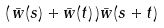Convert formula to latex. <formula><loc_0><loc_0><loc_500><loc_500>( \, \bar { w } ( s ) + \bar { w } ( t ) \, ) \bar { w } ( s + t )</formula> 